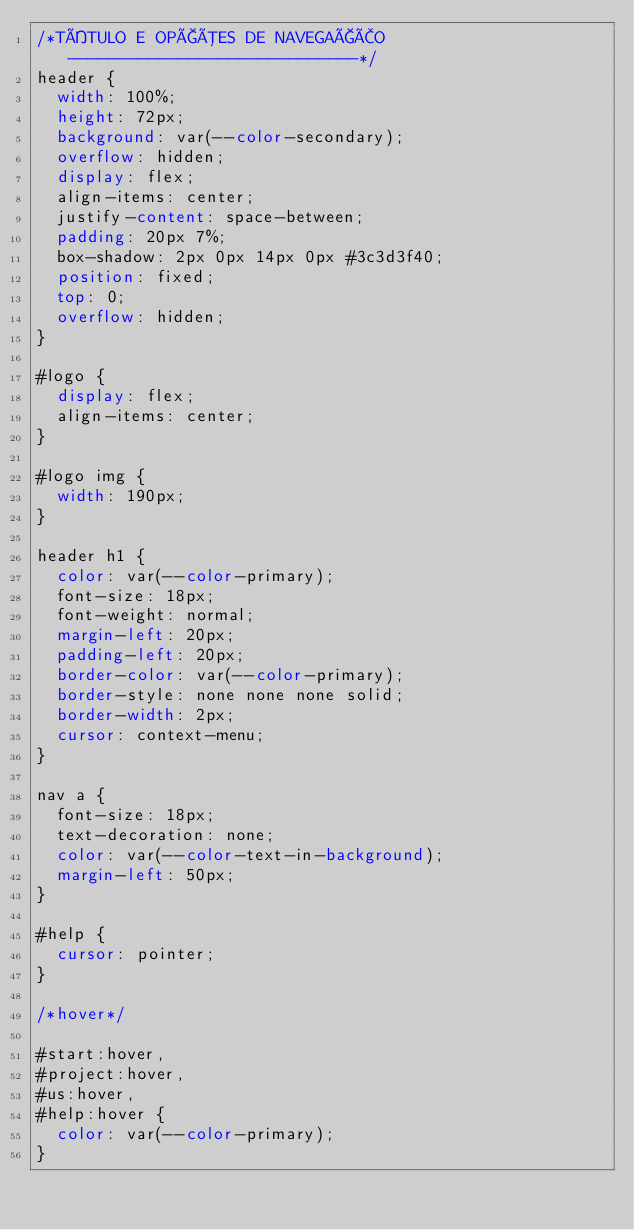<code> <loc_0><loc_0><loc_500><loc_500><_CSS_>/*TÍTULO E OPÇÕES DE NAVEGAÇÃO -----------------------------*/
header {
  width: 100%;
  height: 72px;
  background: var(--color-secondary);
  overflow: hidden;
  display: flex;
  align-items: center;
  justify-content: space-between;
  padding: 20px 7%;
  box-shadow: 2px 0px 14px 0px #3c3d3f40;
  position: fixed;
  top: 0;
  overflow: hidden;
}

#logo {
  display: flex;
  align-items: center;
}

#logo img {
  width: 190px;
}

header h1 {
  color: var(--color-primary);
  font-size: 18px;
  font-weight: normal;
  margin-left: 20px;
  padding-left: 20px;
  border-color: var(--color-primary);
  border-style: none none none solid;
  border-width: 2px;
  cursor: context-menu;
}

nav a {
  font-size: 18px;
  text-decoration: none;
  color: var(--color-text-in-background);
  margin-left: 50px;
}

#help {
  cursor: pointer;
}

/*hover*/

#start:hover,
#project:hover,
#us:hover,
#help:hover {
  color: var(--color-primary);
}
</code> 